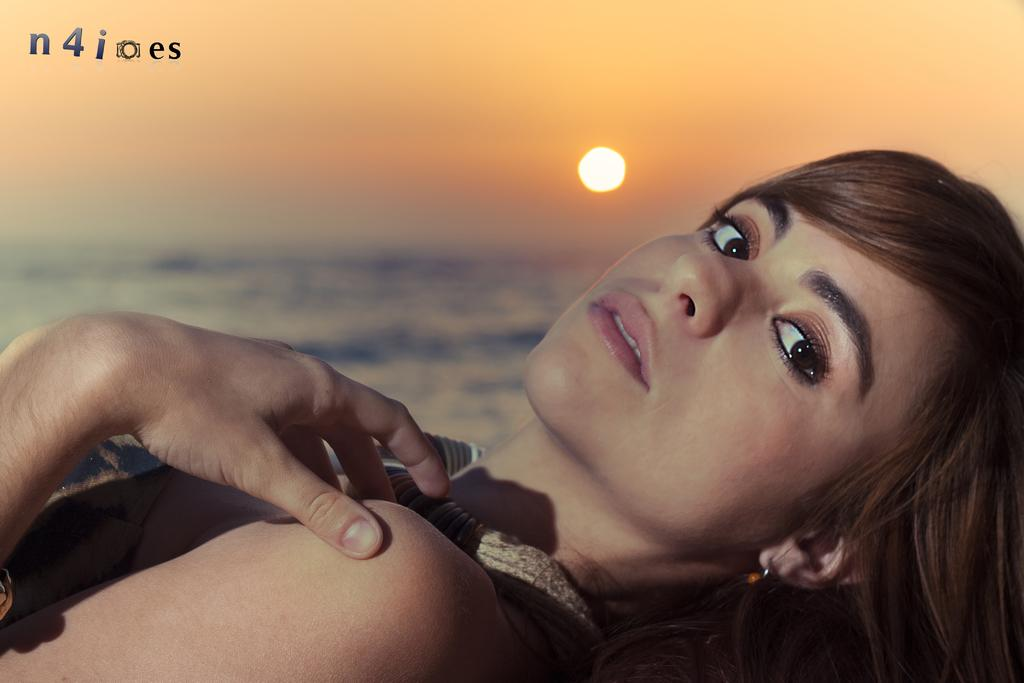Who is the main subject in the foreground of the image? There is a lady in the foreground of the image. What can be seen in the background of the image? Sky, water, and the sun are visible in the background of the image. Is there any text present in the image? Yes, there is some text at the top of the image. What type of base is supporting the lady in the image? There is no base visible in the image; the lady appears to be standing on the ground. What grade of material is used for the shelf in the image? There is no shelf present in the image. 